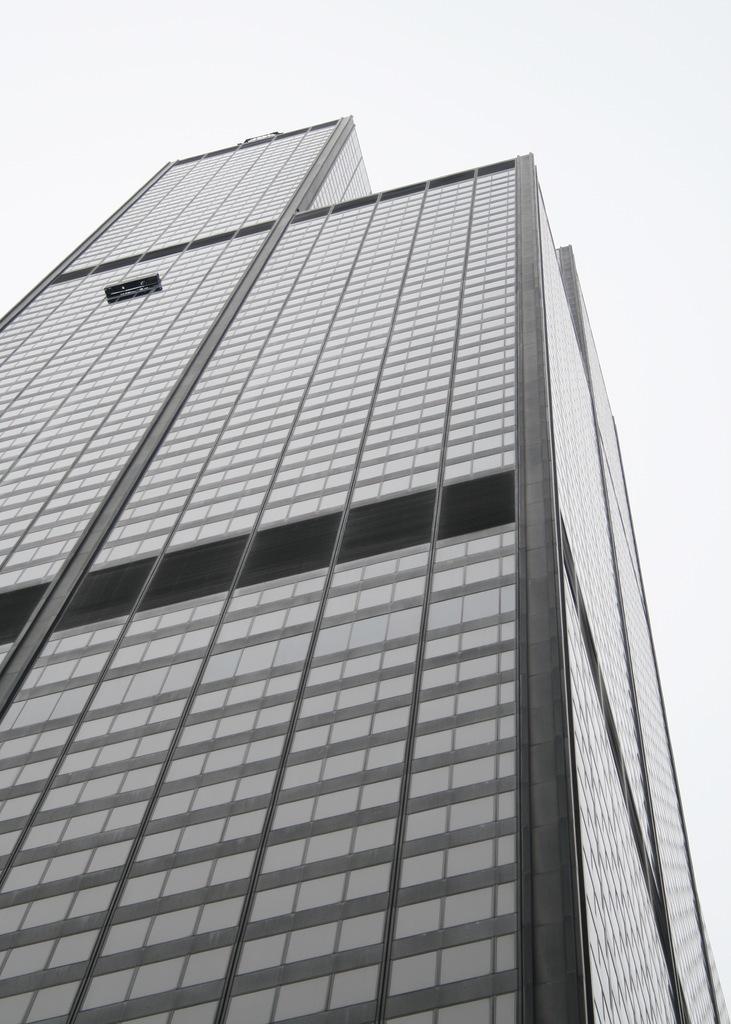Describe this image in one or two sentences. This picture might be taken from outside of the building. In this image, we can see building. In the background, we can also see white color. 